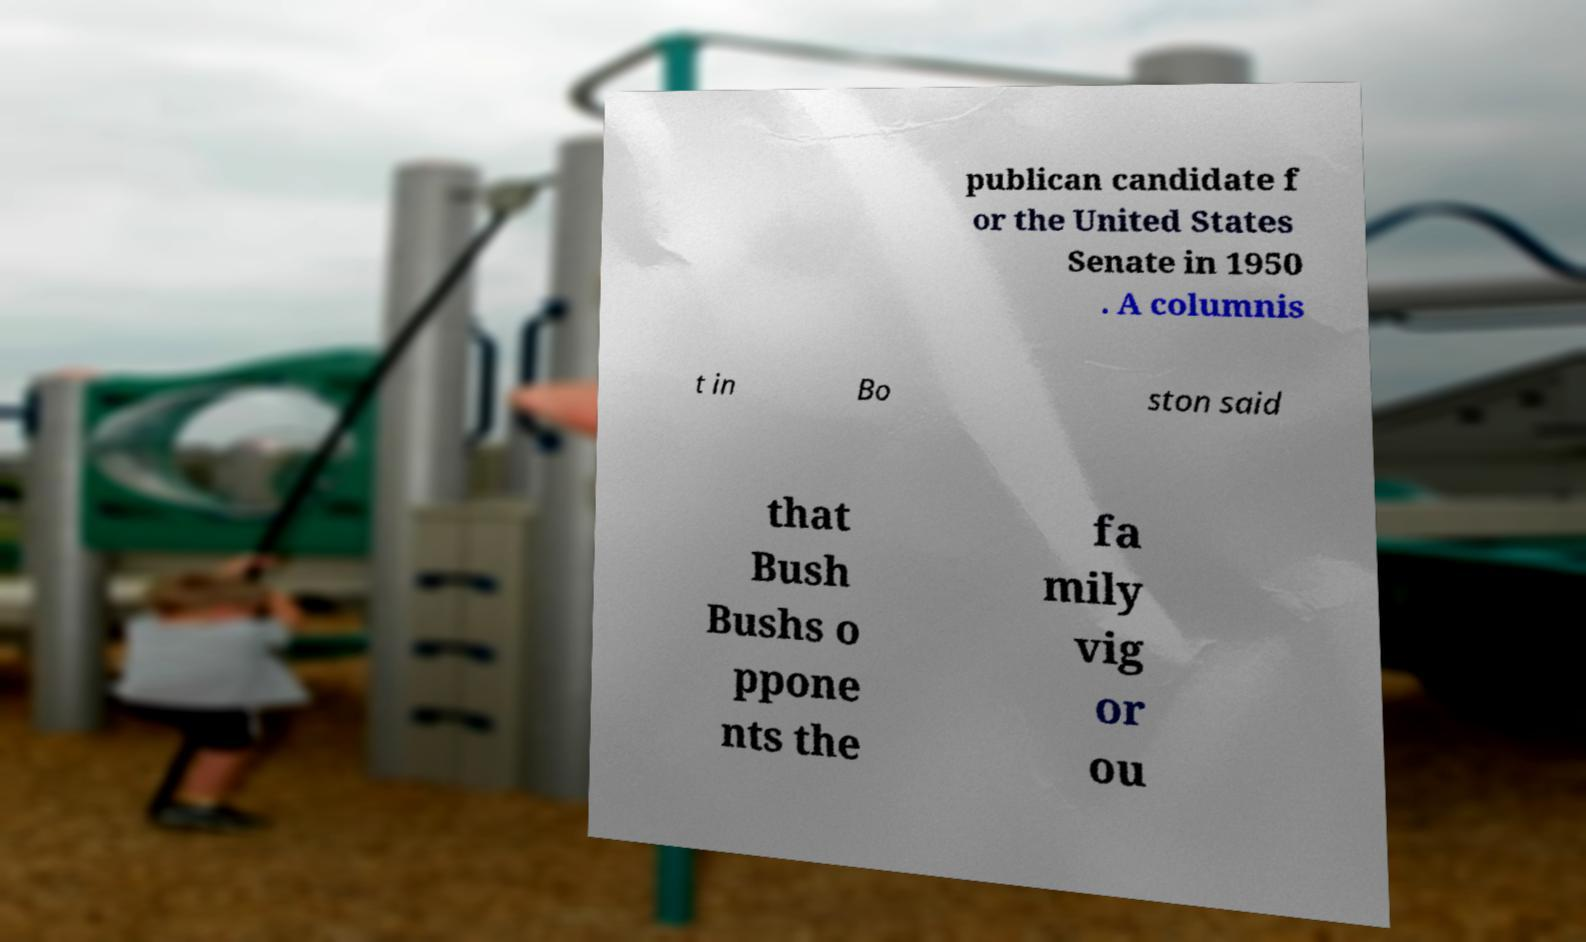Could you assist in decoding the text presented in this image and type it out clearly? publican candidate f or the United States Senate in 1950 . A columnis t in Bo ston said that Bush Bushs o ppone nts the fa mily vig or ou 